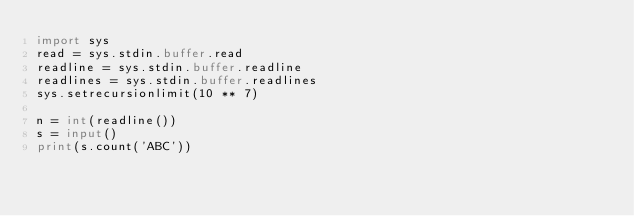<code> <loc_0><loc_0><loc_500><loc_500><_Python_>import sys
read = sys.stdin.buffer.read
readline = sys.stdin.buffer.readline
readlines = sys.stdin.buffer.readlines
sys.setrecursionlimit(10 ** 7)

n = int(readline())
s = input()
print(s.count('ABC'))
</code> 